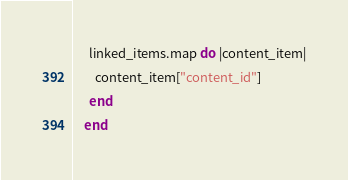<code> <loc_0><loc_0><loc_500><loc_500><_Ruby_>      linked_items.map do |content_item|
        content_item["content_id"]
      end
    end
</code> 